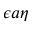Convert formula to latex. <formula><loc_0><loc_0><loc_500><loc_500>\epsilon a \eta</formula> 